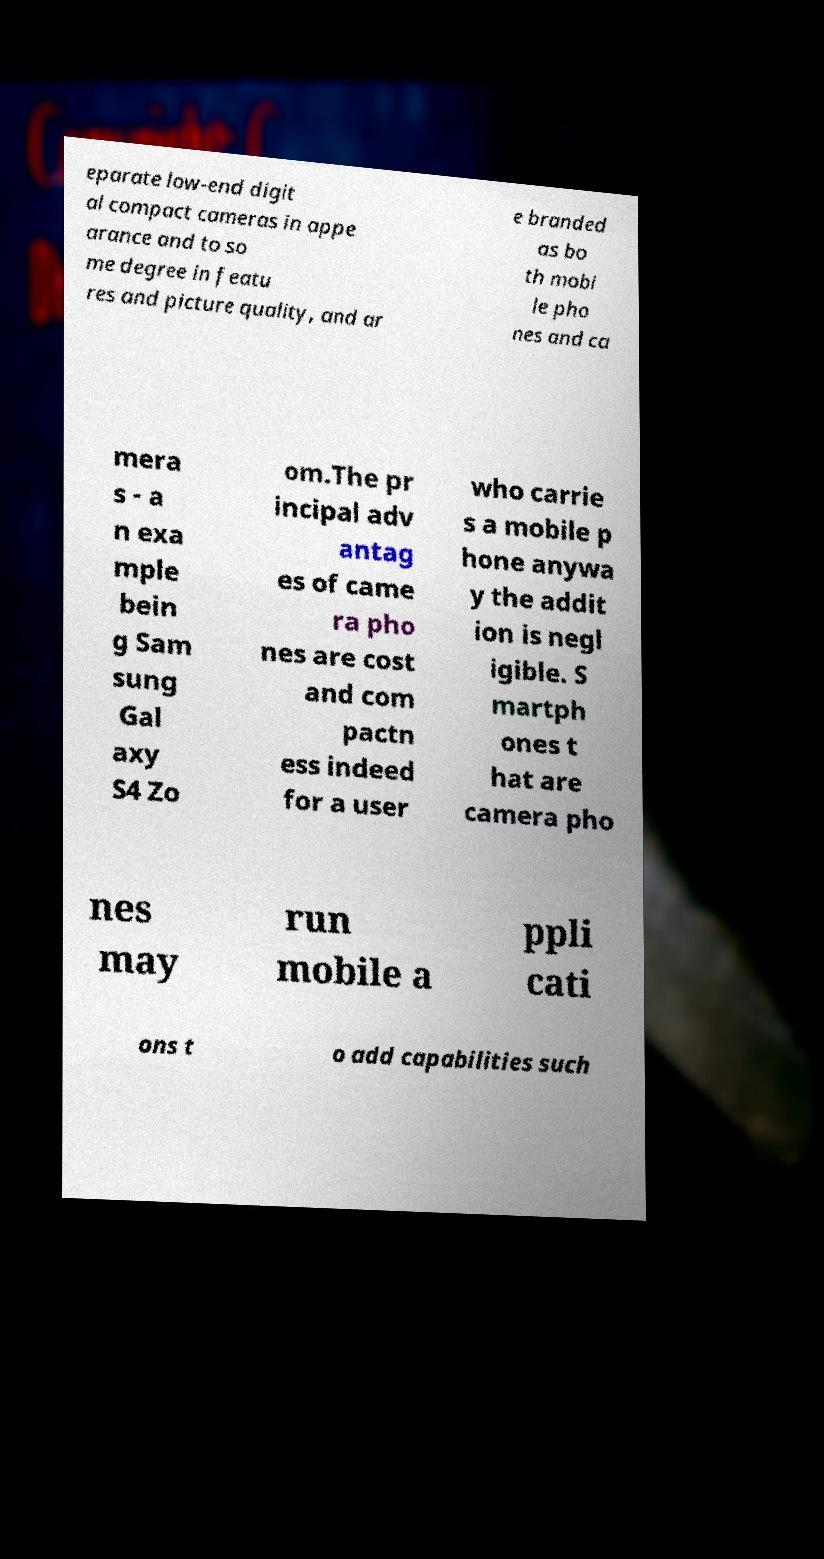What messages or text are displayed in this image? I need them in a readable, typed format. eparate low-end digit al compact cameras in appe arance and to so me degree in featu res and picture quality, and ar e branded as bo th mobi le pho nes and ca mera s - a n exa mple bein g Sam sung Gal axy S4 Zo om.The pr incipal adv antag es of came ra pho nes are cost and com pactn ess indeed for a user who carrie s a mobile p hone anywa y the addit ion is negl igible. S martph ones t hat are camera pho nes may run mobile a ppli cati ons t o add capabilities such 